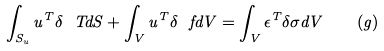<formula> <loc_0><loc_0><loc_500><loc_500>\int _ { S _ { u } } u ^ { T } \delta \ T d S + \int _ { V } u ^ { T } \delta \ f d V = \int _ { V } { \epsilon } ^ { T } \delta { \sigma } d V \quad ( g )</formula> 